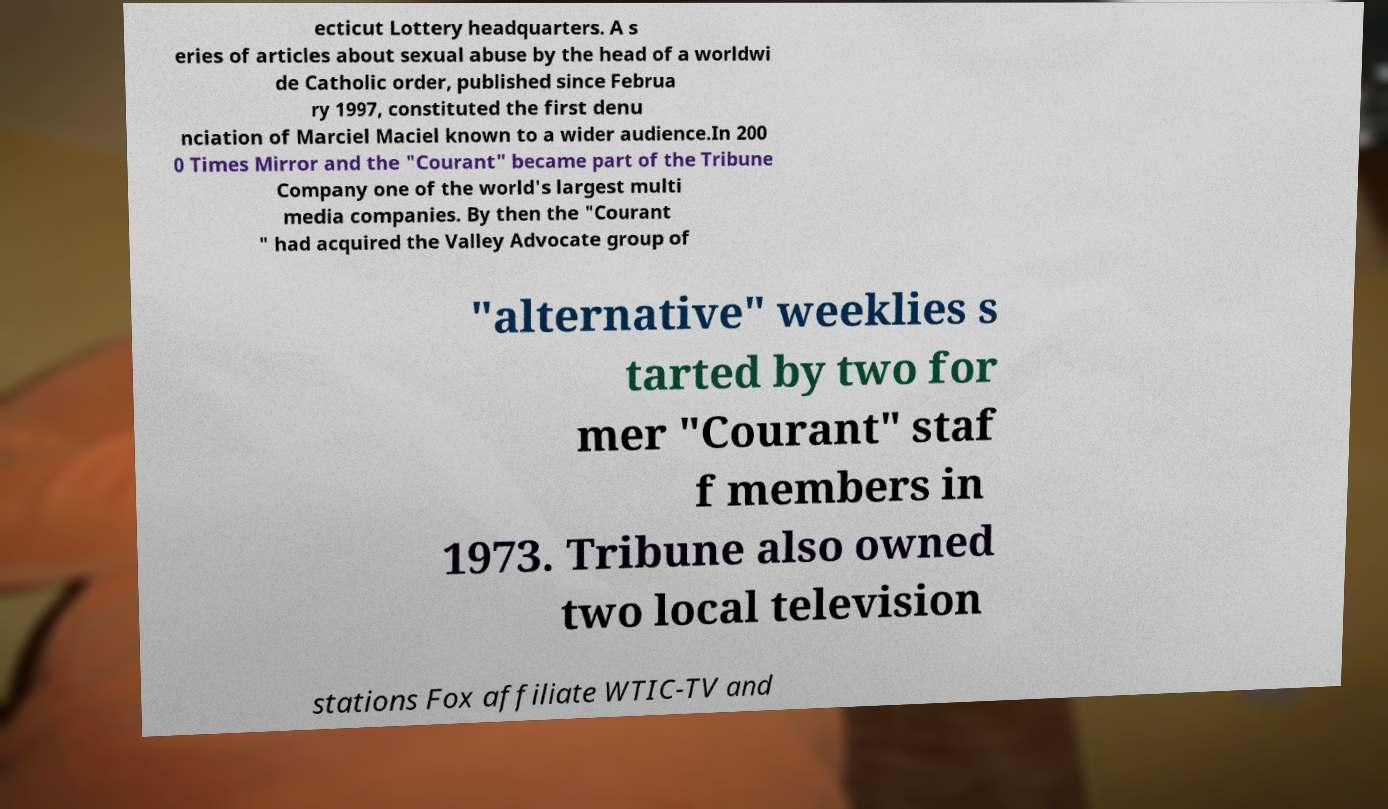Could you assist in decoding the text presented in this image and type it out clearly? ecticut Lottery headquarters. A s eries of articles about sexual abuse by the head of a worldwi de Catholic order, published since Februa ry 1997, constituted the first denu nciation of Marciel Maciel known to a wider audience.In 200 0 Times Mirror and the "Courant" became part of the Tribune Company one of the world's largest multi media companies. By then the "Courant " had acquired the Valley Advocate group of "alternative" weeklies s tarted by two for mer "Courant" staf f members in 1973. Tribune also owned two local television stations Fox affiliate WTIC-TV and 